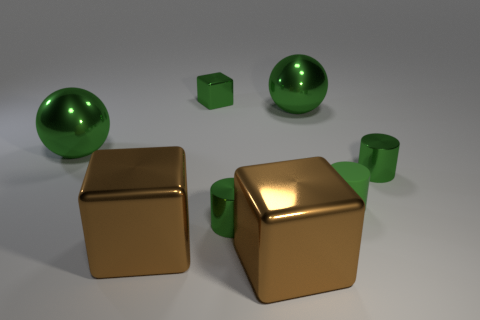Do the tiny matte cylinder and the large cube right of the small green cube have the same color?
Keep it short and to the point. No. There is a large green thing to the right of the green cube; what is it made of?
Provide a succinct answer. Metal. Are there any metal blocks that have the same color as the matte cylinder?
Provide a succinct answer. Yes. There is a matte cylinder that is the same size as the green metallic cube; what color is it?
Ensure brevity in your answer.  Green. What number of big objects are green blocks or balls?
Give a very brief answer. 2. Are there an equal number of small cylinders that are behind the rubber object and small blocks behind the green cube?
Your response must be concise. No. What number of metal cylinders are the same size as the matte thing?
Offer a very short reply. 2. How many cyan objects are small metallic cylinders or metal spheres?
Provide a succinct answer. 0. Is the number of large metallic objects left of the tiny green shiny block the same as the number of big shiny spheres?
Keep it short and to the point. Yes. How big is the cylinder behind the tiny matte cylinder?
Keep it short and to the point. Small. 